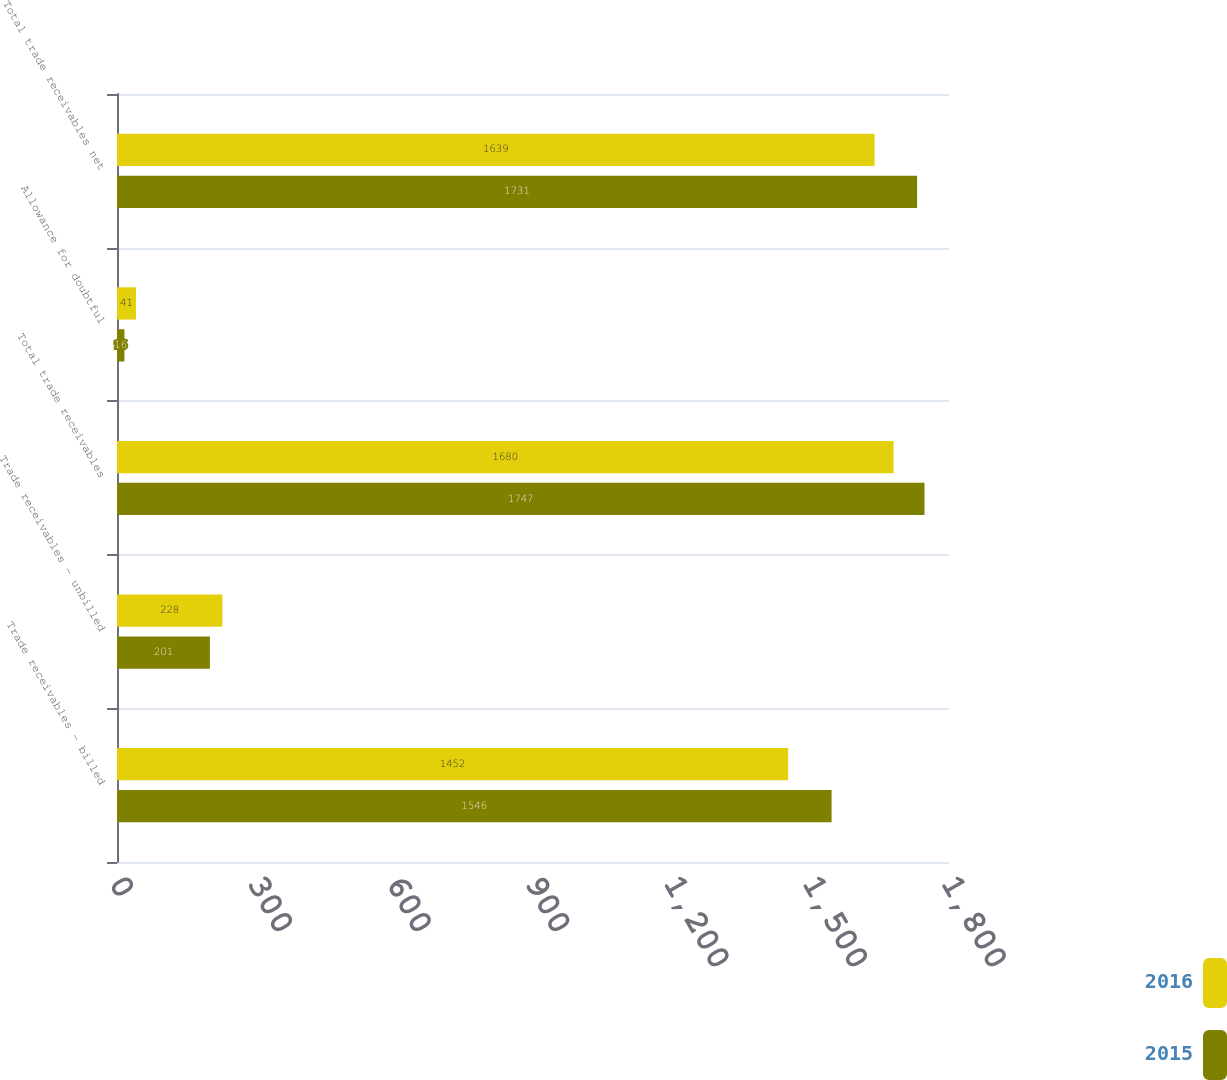Convert chart. <chart><loc_0><loc_0><loc_500><loc_500><stacked_bar_chart><ecel><fcel>Trade receivables - billed<fcel>Trade receivables - unbilled<fcel>Total trade receivables<fcel>Allowance for doubtful<fcel>Total trade receivables net<nl><fcel>2016<fcel>1452<fcel>228<fcel>1680<fcel>41<fcel>1639<nl><fcel>2015<fcel>1546<fcel>201<fcel>1747<fcel>16<fcel>1731<nl></chart> 